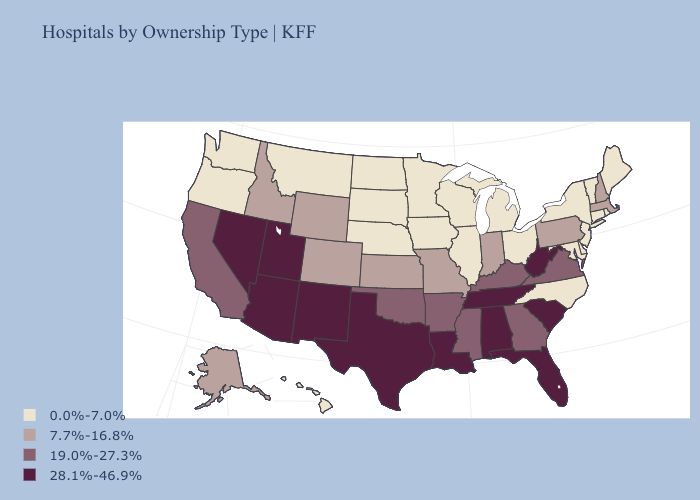Name the states that have a value in the range 0.0%-7.0%?
Keep it brief. Connecticut, Delaware, Hawaii, Illinois, Iowa, Maine, Maryland, Michigan, Minnesota, Montana, Nebraska, New Jersey, New York, North Carolina, North Dakota, Ohio, Oregon, Rhode Island, South Dakota, Vermont, Washington, Wisconsin. Does Arkansas have the lowest value in the South?
Short answer required. No. What is the value of North Carolina?
Quick response, please. 0.0%-7.0%. Does the first symbol in the legend represent the smallest category?
Give a very brief answer. Yes. What is the value of Idaho?
Short answer required. 7.7%-16.8%. What is the value of Louisiana?
Concise answer only. 28.1%-46.9%. Among the states that border New York , which have the lowest value?
Answer briefly. Connecticut, New Jersey, Vermont. Does Oklahoma have the same value as Nevada?
Keep it brief. No. Name the states that have a value in the range 28.1%-46.9%?
Quick response, please. Alabama, Arizona, Florida, Louisiana, Nevada, New Mexico, South Carolina, Tennessee, Texas, Utah, West Virginia. What is the value of Connecticut?
Quick response, please. 0.0%-7.0%. Among the states that border Montana , which have the highest value?
Keep it brief. Idaho, Wyoming. How many symbols are there in the legend?
Concise answer only. 4. Name the states that have a value in the range 0.0%-7.0%?
Quick response, please. Connecticut, Delaware, Hawaii, Illinois, Iowa, Maine, Maryland, Michigan, Minnesota, Montana, Nebraska, New Jersey, New York, North Carolina, North Dakota, Ohio, Oregon, Rhode Island, South Dakota, Vermont, Washington, Wisconsin. Does the first symbol in the legend represent the smallest category?
Concise answer only. Yes. Among the states that border Alabama , which have the highest value?
Concise answer only. Florida, Tennessee. 